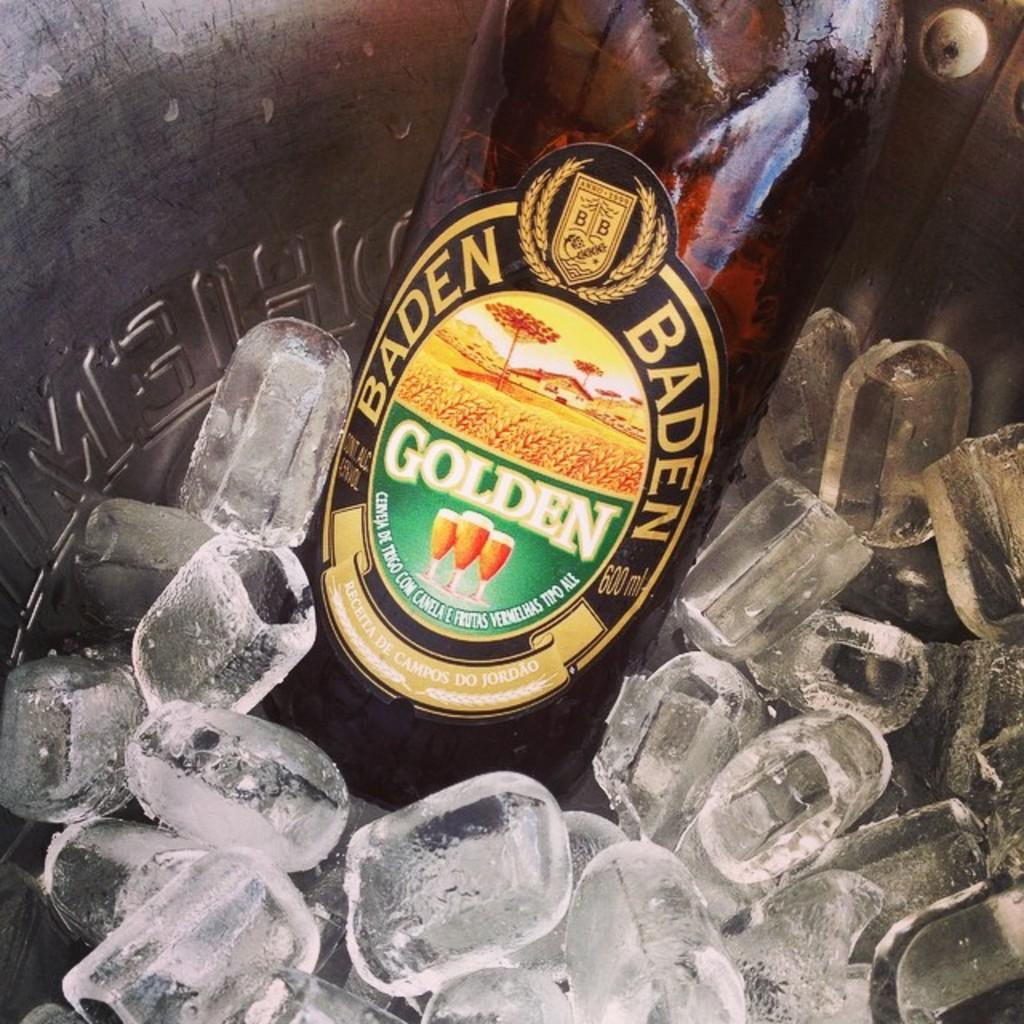Provide a one-sentence caption for the provided image. A container holds ice and a bottle of Baden Golden. 